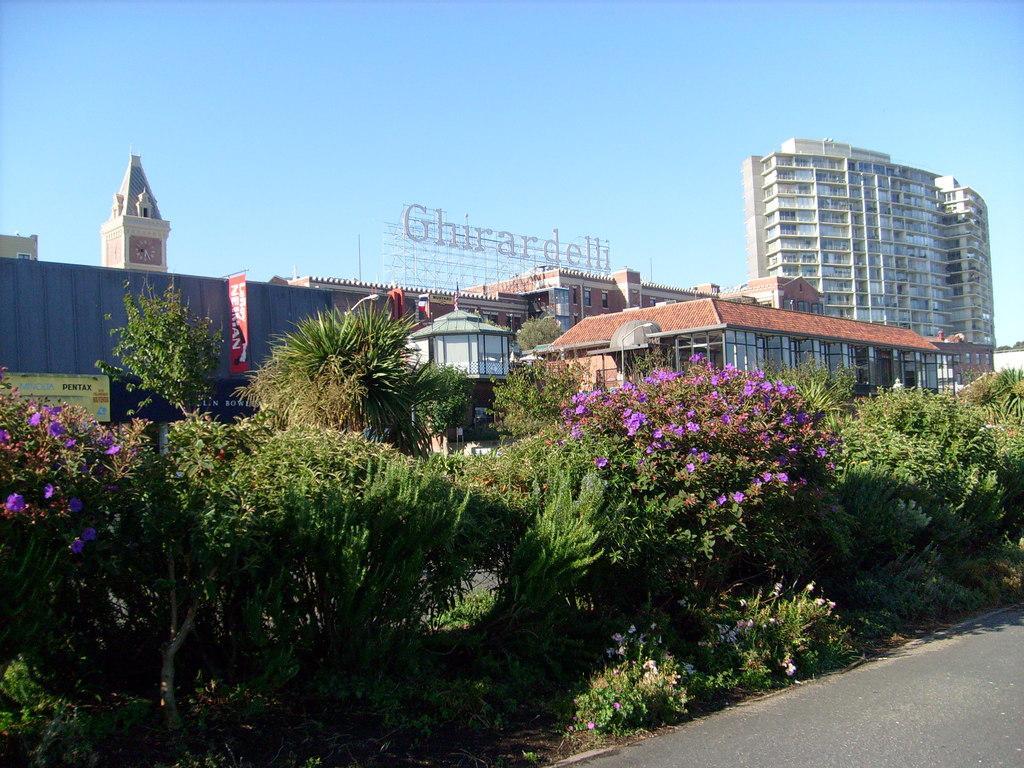Can you describe this image briefly? There is a road in the right side bottom. We can see the trees on the left side. We can see a wall and behind that we can see a church and on the right side we can see a tall building. In the middle we can see a name Ghirardelli. 